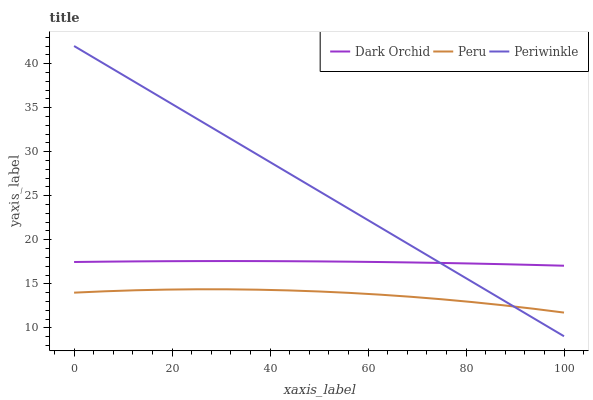Does Peru have the minimum area under the curve?
Answer yes or no. Yes. Does Periwinkle have the maximum area under the curve?
Answer yes or no. Yes. Does Dark Orchid have the minimum area under the curve?
Answer yes or no. No. Does Dark Orchid have the maximum area under the curve?
Answer yes or no. No. Is Periwinkle the smoothest?
Answer yes or no. Yes. Is Peru the roughest?
Answer yes or no. Yes. Is Dark Orchid the smoothest?
Answer yes or no. No. Is Dark Orchid the roughest?
Answer yes or no. No. Does Peru have the lowest value?
Answer yes or no. No. Does Periwinkle have the highest value?
Answer yes or no. Yes. Does Dark Orchid have the highest value?
Answer yes or no. No. Is Peru less than Dark Orchid?
Answer yes or no. Yes. Is Dark Orchid greater than Peru?
Answer yes or no. Yes. Does Periwinkle intersect Peru?
Answer yes or no. Yes. Is Periwinkle less than Peru?
Answer yes or no. No. Is Periwinkle greater than Peru?
Answer yes or no. No. Does Peru intersect Dark Orchid?
Answer yes or no. No. 